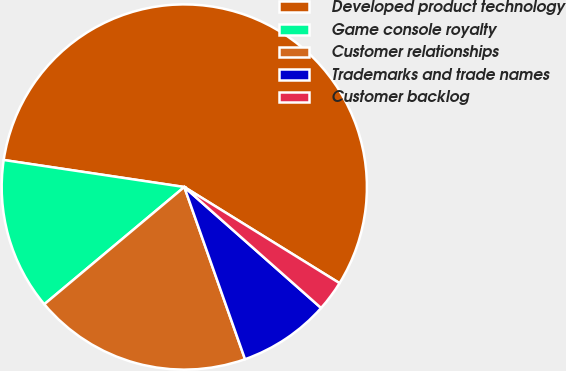<chart> <loc_0><loc_0><loc_500><loc_500><pie_chart><fcel>Developed product technology<fcel>Game console royalty<fcel>Customer relationships<fcel>Trademarks and trade names<fcel>Customer backlog<nl><fcel>56.46%<fcel>13.46%<fcel>19.3%<fcel>8.08%<fcel>2.7%<nl></chart> 